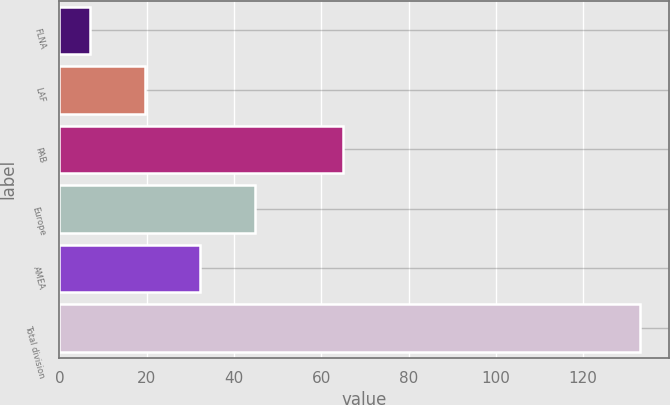Convert chart to OTSL. <chart><loc_0><loc_0><loc_500><loc_500><bar_chart><fcel>FLNA<fcel>LAF<fcel>PAB<fcel>Europe<fcel>AMEA<fcel>Total division<nl><fcel>7<fcel>19.6<fcel>65<fcel>44.8<fcel>32.2<fcel>133<nl></chart> 